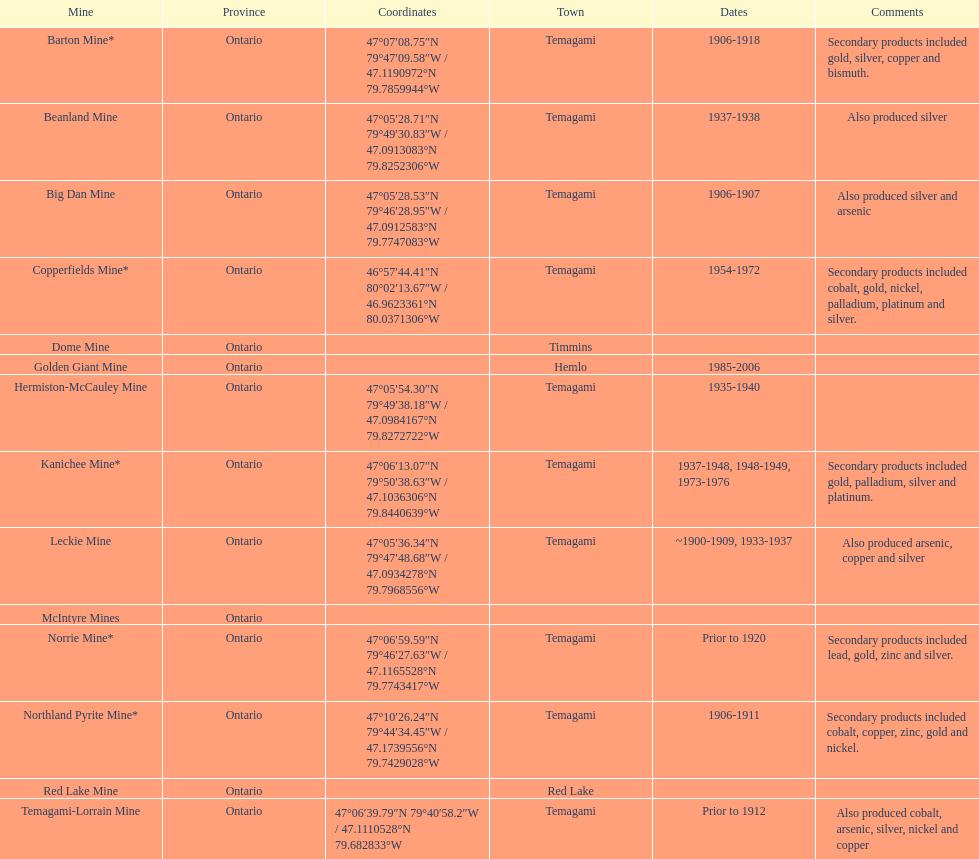Where can bismuth be found in a mine? Barton Mine. 